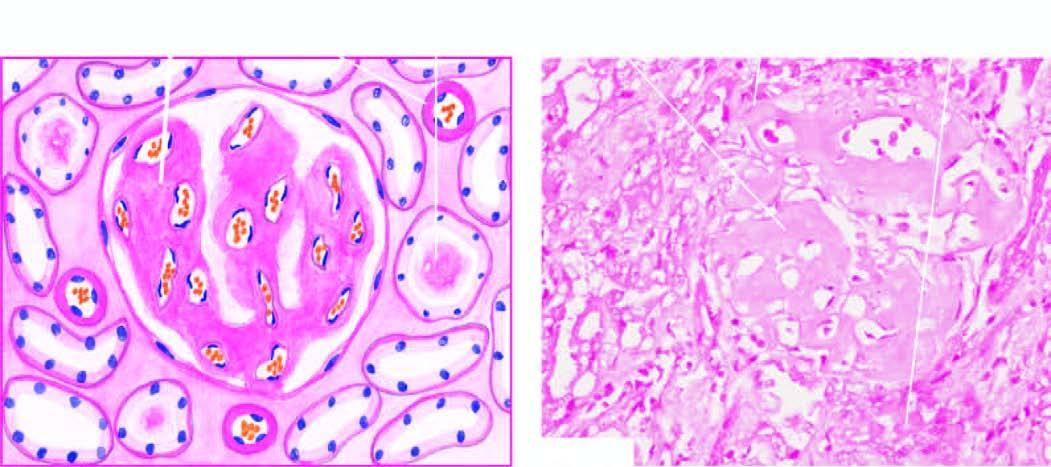s p-component also present in peritubular connective tissue producing atrophic tubules?
Answer the question using a single word or phrase. No 